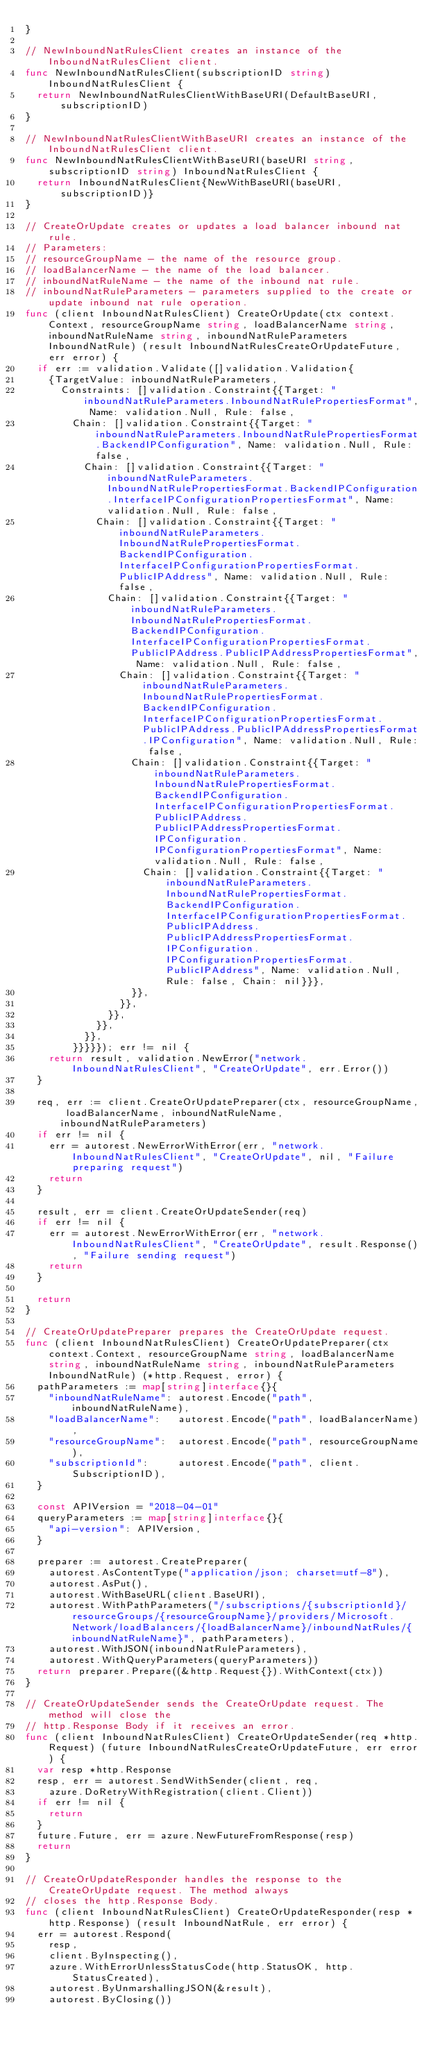Convert code to text. <code><loc_0><loc_0><loc_500><loc_500><_Go_>}

// NewInboundNatRulesClient creates an instance of the InboundNatRulesClient client.
func NewInboundNatRulesClient(subscriptionID string) InboundNatRulesClient {
	return NewInboundNatRulesClientWithBaseURI(DefaultBaseURI, subscriptionID)
}

// NewInboundNatRulesClientWithBaseURI creates an instance of the InboundNatRulesClient client.
func NewInboundNatRulesClientWithBaseURI(baseURI string, subscriptionID string) InboundNatRulesClient {
	return InboundNatRulesClient{NewWithBaseURI(baseURI, subscriptionID)}
}

// CreateOrUpdate creates or updates a load balancer inbound nat rule.
// Parameters:
// resourceGroupName - the name of the resource group.
// loadBalancerName - the name of the load balancer.
// inboundNatRuleName - the name of the inbound nat rule.
// inboundNatRuleParameters - parameters supplied to the create or update inbound nat rule operation.
func (client InboundNatRulesClient) CreateOrUpdate(ctx context.Context, resourceGroupName string, loadBalancerName string, inboundNatRuleName string, inboundNatRuleParameters InboundNatRule) (result InboundNatRulesCreateOrUpdateFuture, err error) {
	if err := validation.Validate([]validation.Validation{
		{TargetValue: inboundNatRuleParameters,
			Constraints: []validation.Constraint{{Target: "inboundNatRuleParameters.InboundNatRulePropertiesFormat", Name: validation.Null, Rule: false,
				Chain: []validation.Constraint{{Target: "inboundNatRuleParameters.InboundNatRulePropertiesFormat.BackendIPConfiguration", Name: validation.Null, Rule: false,
					Chain: []validation.Constraint{{Target: "inboundNatRuleParameters.InboundNatRulePropertiesFormat.BackendIPConfiguration.InterfaceIPConfigurationPropertiesFormat", Name: validation.Null, Rule: false,
						Chain: []validation.Constraint{{Target: "inboundNatRuleParameters.InboundNatRulePropertiesFormat.BackendIPConfiguration.InterfaceIPConfigurationPropertiesFormat.PublicIPAddress", Name: validation.Null, Rule: false,
							Chain: []validation.Constraint{{Target: "inboundNatRuleParameters.InboundNatRulePropertiesFormat.BackendIPConfiguration.InterfaceIPConfigurationPropertiesFormat.PublicIPAddress.PublicIPAddressPropertiesFormat", Name: validation.Null, Rule: false,
								Chain: []validation.Constraint{{Target: "inboundNatRuleParameters.InboundNatRulePropertiesFormat.BackendIPConfiguration.InterfaceIPConfigurationPropertiesFormat.PublicIPAddress.PublicIPAddressPropertiesFormat.IPConfiguration", Name: validation.Null, Rule: false,
									Chain: []validation.Constraint{{Target: "inboundNatRuleParameters.InboundNatRulePropertiesFormat.BackendIPConfiguration.InterfaceIPConfigurationPropertiesFormat.PublicIPAddress.PublicIPAddressPropertiesFormat.IPConfiguration.IPConfigurationPropertiesFormat", Name: validation.Null, Rule: false,
										Chain: []validation.Constraint{{Target: "inboundNatRuleParameters.InboundNatRulePropertiesFormat.BackendIPConfiguration.InterfaceIPConfigurationPropertiesFormat.PublicIPAddress.PublicIPAddressPropertiesFormat.IPConfiguration.IPConfigurationPropertiesFormat.PublicIPAddress", Name: validation.Null, Rule: false, Chain: nil}}},
									}},
								}},
							}},
						}},
					}},
				}}}}}); err != nil {
		return result, validation.NewError("network.InboundNatRulesClient", "CreateOrUpdate", err.Error())
	}

	req, err := client.CreateOrUpdatePreparer(ctx, resourceGroupName, loadBalancerName, inboundNatRuleName, inboundNatRuleParameters)
	if err != nil {
		err = autorest.NewErrorWithError(err, "network.InboundNatRulesClient", "CreateOrUpdate", nil, "Failure preparing request")
		return
	}

	result, err = client.CreateOrUpdateSender(req)
	if err != nil {
		err = autorest.NewErrorWithError(err, "network.InboundNatRulesClient", "CreateOrUpdate", result.Response(), "Failure sending request")
		return
	}

	return
}

// CreateOrUpdatePreparer prepares the CreateOrUpdate request.
func (client InboundNatRulesClient) CreateOrUpdatePreparer(ctx context.Context, resourceGroupName string, loadBalancerName string, inboundNatRuleName string, inboundNatRuleParameters InboundNatRule) (*http.Request, error) {
	pathParameters := map[string]interface{}{
		"inboundNatRuleName": autorest.Encode("path", inboundNatRuleName),
		"loadBalancerName":   autorest.Encode("path", loadBalancerName),
		"resourceGroupName":  autorest.Encode("path", resourceGroupName),
		"subscriptionId":     autorest.Encode("path", client.SubscriptionID),
	}

	const APIVersion = "2018-04-01"
	queryParameters := map[string]interface{}{
		"api-version": APIVersion,
	}

	preparer := autorest.CreatePreparer(
		autorest.AsContentType("application/json; charset=utf-8"),
		autorest.AsPut(),
		autorest.WithBaseURL(client.BaseURI),
		autorest.WithPathParameters("/subscriptions/{subscriptionId}/resourceGroups/{resourceGroupName}/providers/Microsoft.Network/loadBalancers/{loadBalancerName}/inboundNatRules/{inboundNatRuleName}", pathParameters),
		autorest.WithJSON(inboundNatRuleParameters),
		autorest.WithQueryParameters(queryParameters))
	return preparer.Prepare((&http.Request{}).WithContext(ctx))
}

// CreateOrUpdateSender sends the CreateOrUpdate request. The method will close the
// http.Response Body if it receives an error.
func (client InboundNatRulesClient) CreateOrUpdateSender(req *http.Request) (future InboundNatRulesCreateOrUpdateFuture, err error) {
	var resp *http.Response
	resp, err = autorest.SendWithSender(client, req,
		azure.DoRetryWithRegistration(client.Client))
	if err != nil {
		return
	}
	future.Future, err = azure.NewFutureFromResponse(resp)
	return
}

// CreateOrUpdateResponder handles the response to the CreateOrUpdate request. The method always
// closes the http.Response Body.
func (client InboundNatRulesClient) CreateOrUpdateResponder(resp *http.Response) (result InboundNatRule, err error) {
	err = autorest.Respond(
		resp,
		client.ByInspecting(),
		azure.WithErrorUnlessStatusCode(http.StatusOK, http.StatusCreated),
		autorest.ByUnmarshallingJSON(&result),
		autorest.ByClosing())</code> 